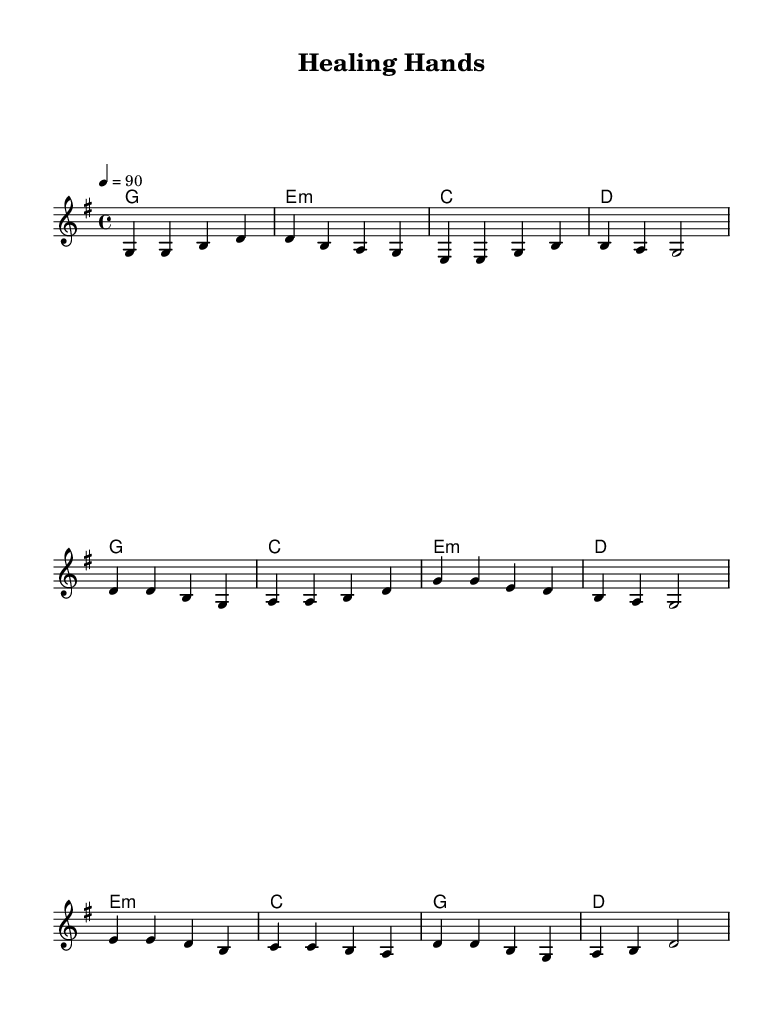What is the key signature of this music? The key signature is indicated at the beginning of the staff, which shows one sharp, meaning it is in G major.
Answer: G major What is the time signature of the piece? The time signature is shown at the beginning, indicating it is 4/4, which means there are four beats in each measure.
Answer: 4/4 What is the tempo marking of the piece? The tempo marking is also found at the beginning of the score and states “4 = 90,” indicating that there are 90 beats per minute for each quarter note.
Answer: 90 How many measures are in the verse? By counting the number of groups of notes designated for the verse section, we can find that there are four measures in total.
Answer: 4 What is the last chord of the bridge? We can look at the harmonies section and find that the last chord listed in the bridge is D major.
Answer: D What type of progression is used in the chorus? The chorus follows a simple I-IV-vi-V progression, which is common in country rock music, suggesting an uplifting and accessible sound.
Answer: I-IV-vi-V What aspect of country rock does this music embody? The reflective melodies combined with lyrics centered on themes of service and strength indicate that this piece embodies the supportive and community-focused aspect of country rock.
Answer: Supportive community-focused 